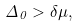Convert formula to latex. <formula><loc_0><loc_0><loc_500><loc_500>\Delta _ { 0 } > \delta \mu ,</formula> 